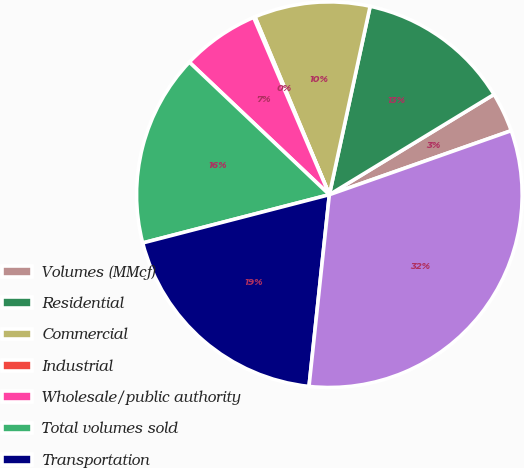Convert chart. <chart><loc_0><loc_0><loc_500><loc_500><pie_chart><fcel>Volumes (MMcf)<fcel>Residential<fcel>Commercial<fcel>Industrial<fcel>Wholesale/public authority<fcel>Total volumes sold<fcel>Transportation<fcel>Total volumes delivered<nl><fcel>3.32%<fcel>12.9%<fcel>9.7%<fcel>0.12%<fcel>6.51%<fcel>16.09%<fcel>19.29%<fcel>32.07%<nl></chart> 